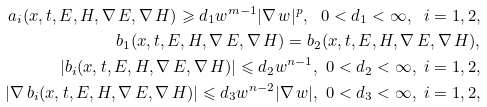Convert formula to latex. <formula><loc_0><loc_0><loc_500><loc_500>a _ { i } ( x , t , E , H , \nabla \, E , \nabla \, H ) \geqslant d _ { 1 } w ^ { m - 1 } | \nabla \, w | ^ { p } , \ 0 < d _ { 1 } < \infty , \ i = 1 , 2 , \\ b _ { 1 } ( x , t , E , H , \nabla \, E , \nabla \, H ) = b _ { 2 } ( x , t , E , H , \nabla \, E , \nabla \, H ) , \\ | b _ { i } ( x , t , E , H , \nabla \, E , \nabla \, H ) | \leqslant d _ { 2 } w ^ { n - 1 } , \ 0 < d _ { 2 } < \infty , \ i = 1 , 2 , \\ | \nabla \, b _ { i } ( x , t , E , H , \nabla \, E , \nabla \, H ) | \leqslant d _ { 3 } w ^ { n - 2 } | \nabla \, w | , \ 0 < d _ { 3 } < \infty , \ i = 1 , 2 ,</formula> 